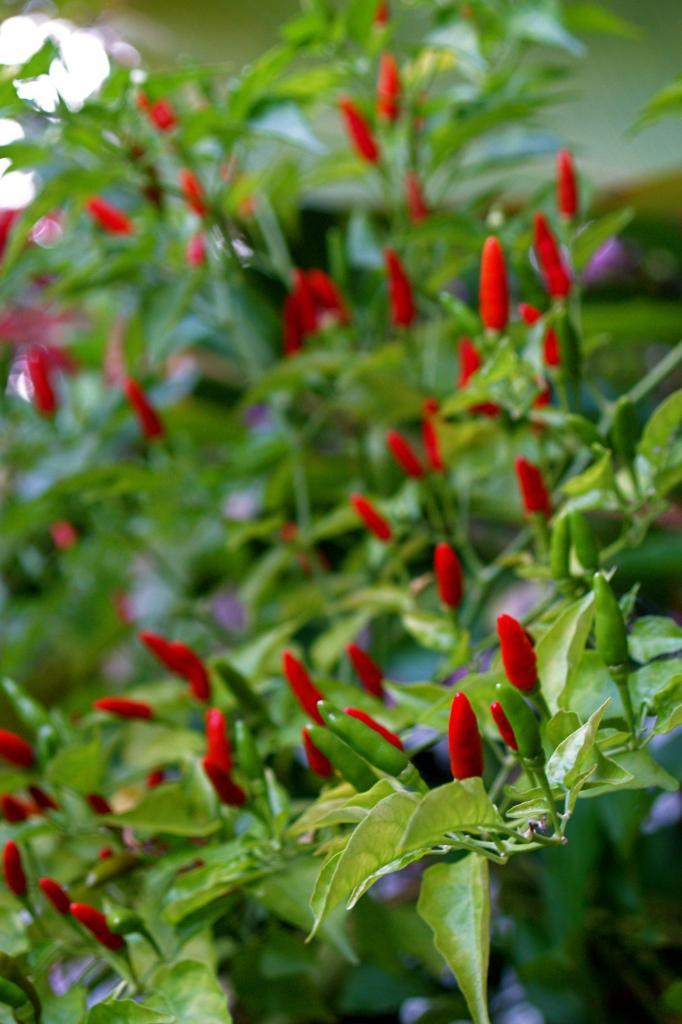What type of vegetation is present in the image? There are leaves in the image. What color are the leaves? The leaves are green. What other objects can be seen in the image? There are chillies in the image. What colors are the chillies? The chillies are red and green. What type of box is used to store the peace in the image? There is no box or peace present in the image; it only features leaves and chillies. What kind of beast can be seen interacting with the chillies in the image? There is no beast present in the image; it only features leaves and chillies. 